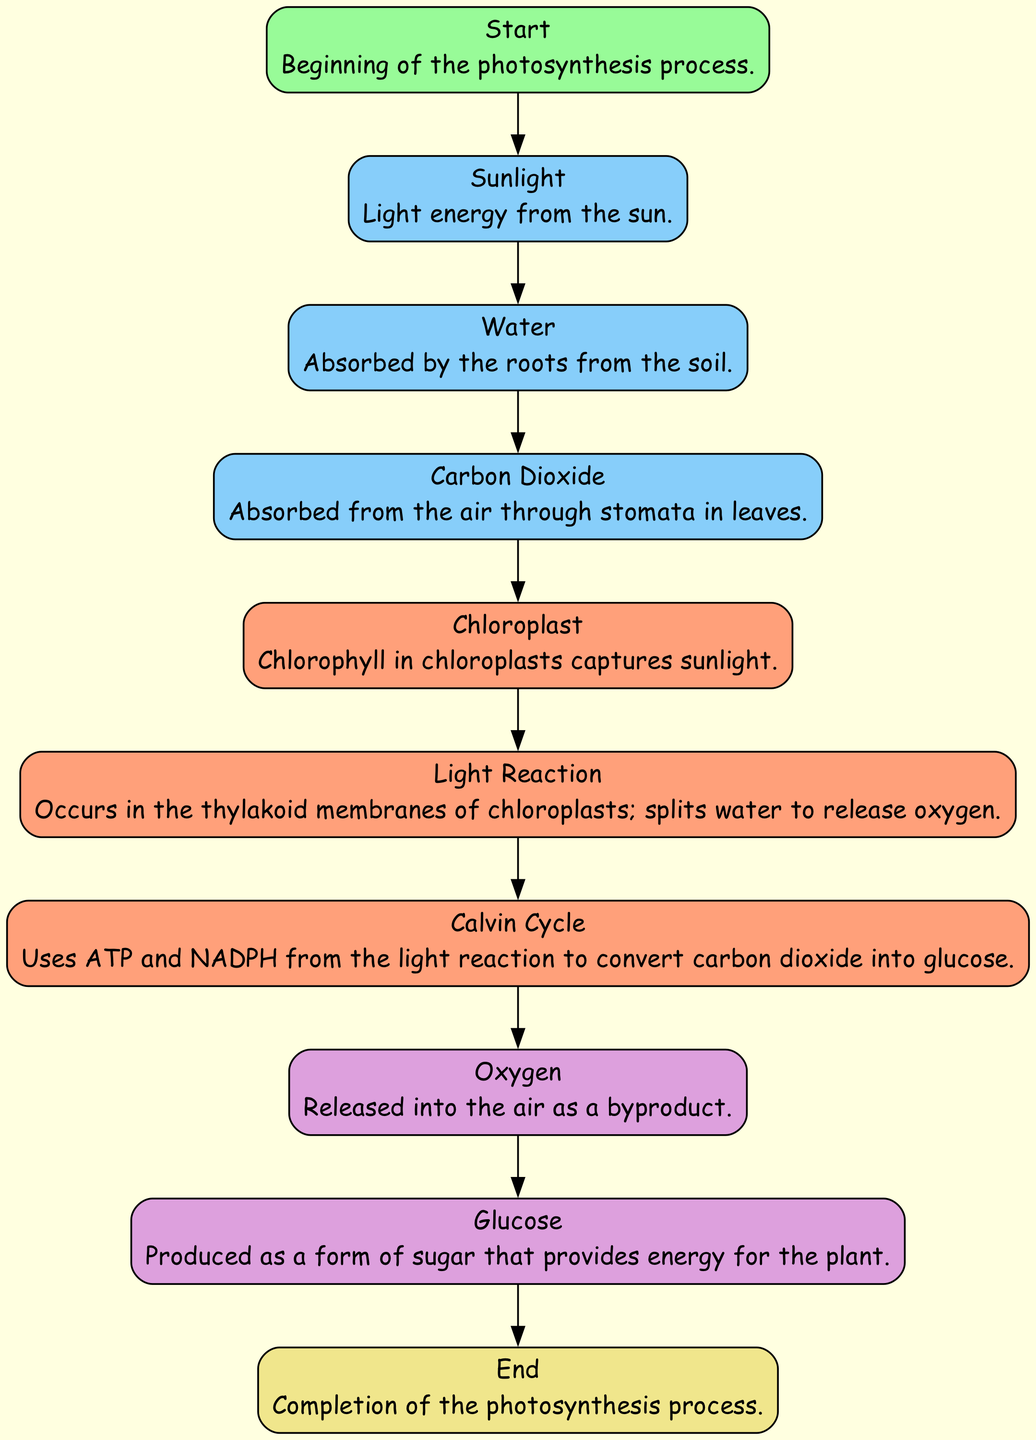What is the first step in the photosynthesis process? The first step is labeled as "Start" in the diagram, indicating the beginning of the photosynthesis process.
Answer: Start How many input nodes are in the diagram? The diagram includes three input nodes: "Sunlight," "Water," and "Carbon Dioxide." Therefore, the total number of input nodes is three.
Answer: 3 What is captured in the chloroplasts? The chloroplast node states that chlorophyll in chloroplasts captures sunlight, which is essential for photosynthesis.
Answer: Sunlight Which output is produced as a byproduct of photosynthesis? The diagram identifies "Oxygen" as the output released into the air as a byproduct of the light reaction during photosynthesis.
Answer: Oxygen What process converts carbon dioxide into glucose? The "Calvin Cycle" is the process that uses ATP and NADPH from the light reaction to convert carbon dioxide into glucose, as indicated in the diagram.
Answer: Calvin Cycle What happens after water is split during the light reaction? After the light reaction occurs and water is split, oxygen is released as a byproduct, as shown in the flow of the diagram leading to the "Oxygen" output node.
Answer: Oxygen What is the final step of the photosynthesis process? The final step is labeled as "End" in the diagram, representing the completion of the photosynthesis process after glucose and oxygen are produced.
Answer: End Which input is absorbed from the air? The "Carbon Dioxide" input is specifically noted in the diagram as being absorbed from the air through stomata in leaves.
Answer: Carbon Dioxide What process directly utilizes the outputs from the light reaction? The "Calvin Cycle" directly utilizes ATP and NADPH produced from the light reaction to convert carbon dioxide into glucose, according to the information in the diagram.
Answer: Calvin Cycle 